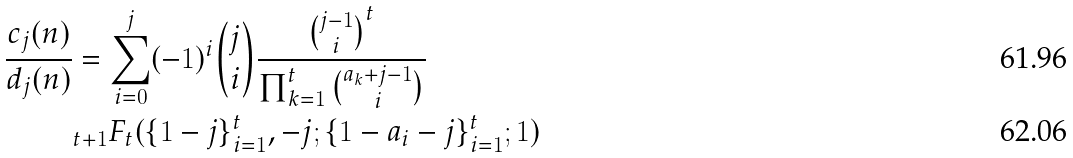Convert formula to latex. <formula><loc_0><loc_0><loc_500><loc_500>\frac { c _ { j } ( n ) } { d _ { j } ( n ) } & = \sum _ { i = 0 } ^ { j } ( - 1 ) ^ { i } { j \choose i } \frac { { j - 1 \choose i } ^ { t } } { \prod _ { k = 1 } ^ { t } { a _ { k } + j - 1 \choose i } } \\ & _ { t + 1 } F _ { t } ( \{ 1 - j \} _ { i = 1 } ^ { t } , - j ; \{ 1 - a _ { i } - j \} ^ { t } _ { i = 1 } ; 1 )</formula> 